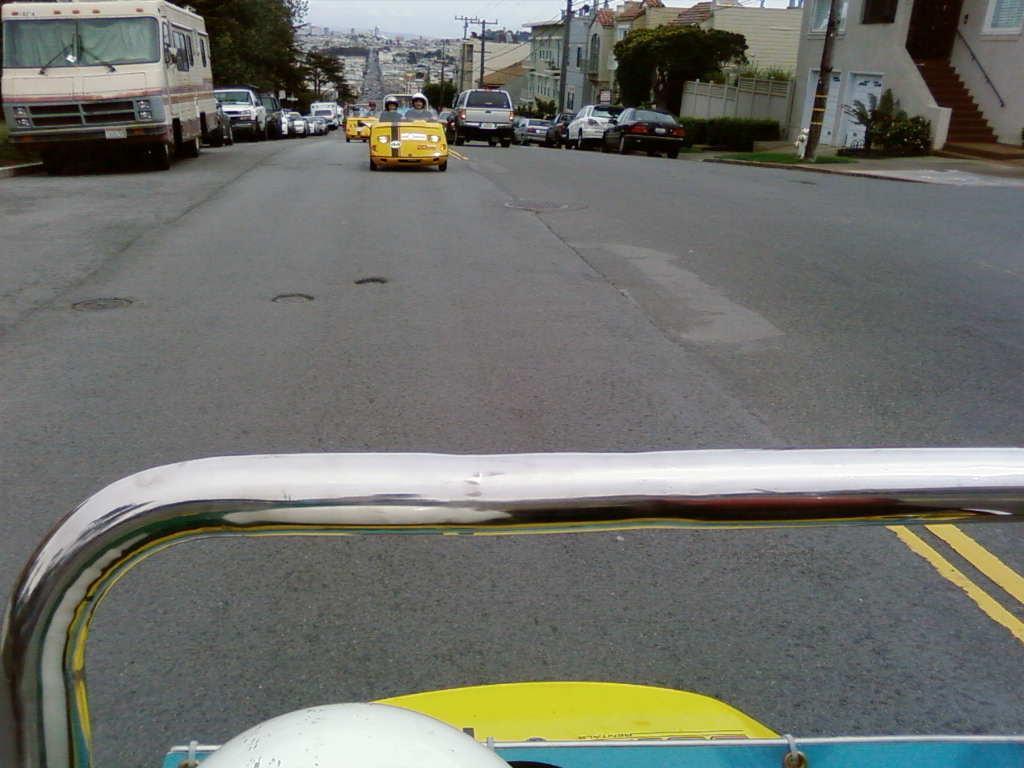Please provide a concise description of this image. This picture is clicked outside. In the foreground we can see a metal rod and some other items. In the center we can see the group of vehicles in which some of them are parked on the ground and some of them are running on the road. In the background we can see the sky, trees, poles, buildings, plants and a staircase and some other items. 